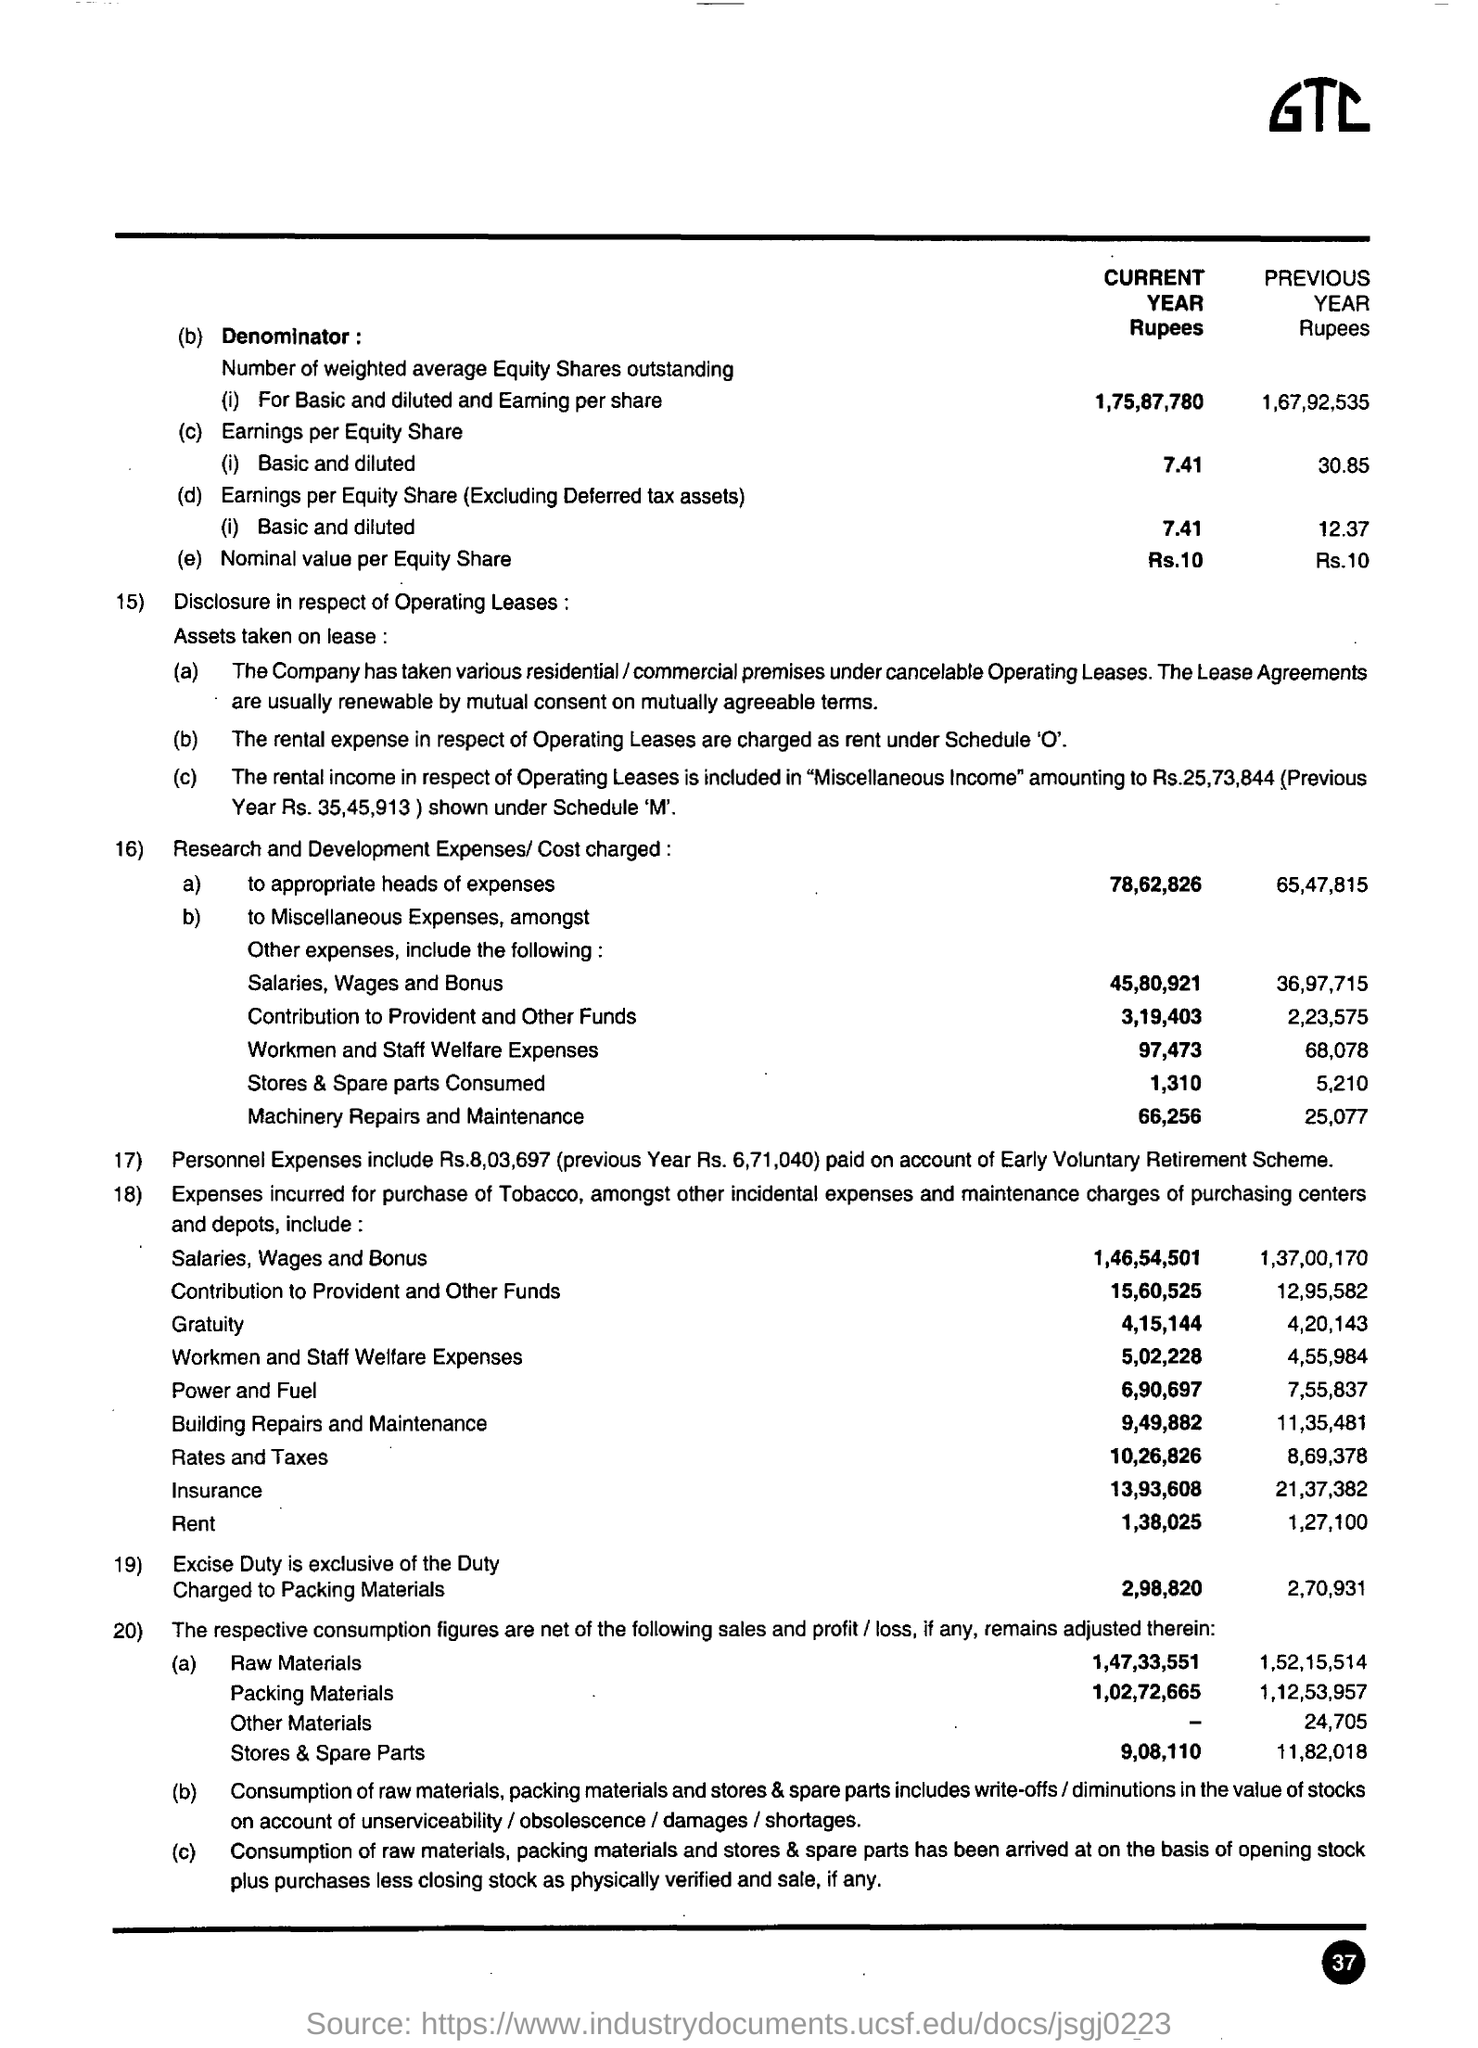Give some essential details in this illustration. The nominal value per equity share for the current year is Rs. 10. The weighted average equity shares outstanding for basic and diluted earnings per share for the current year are 1,75,87,780. 